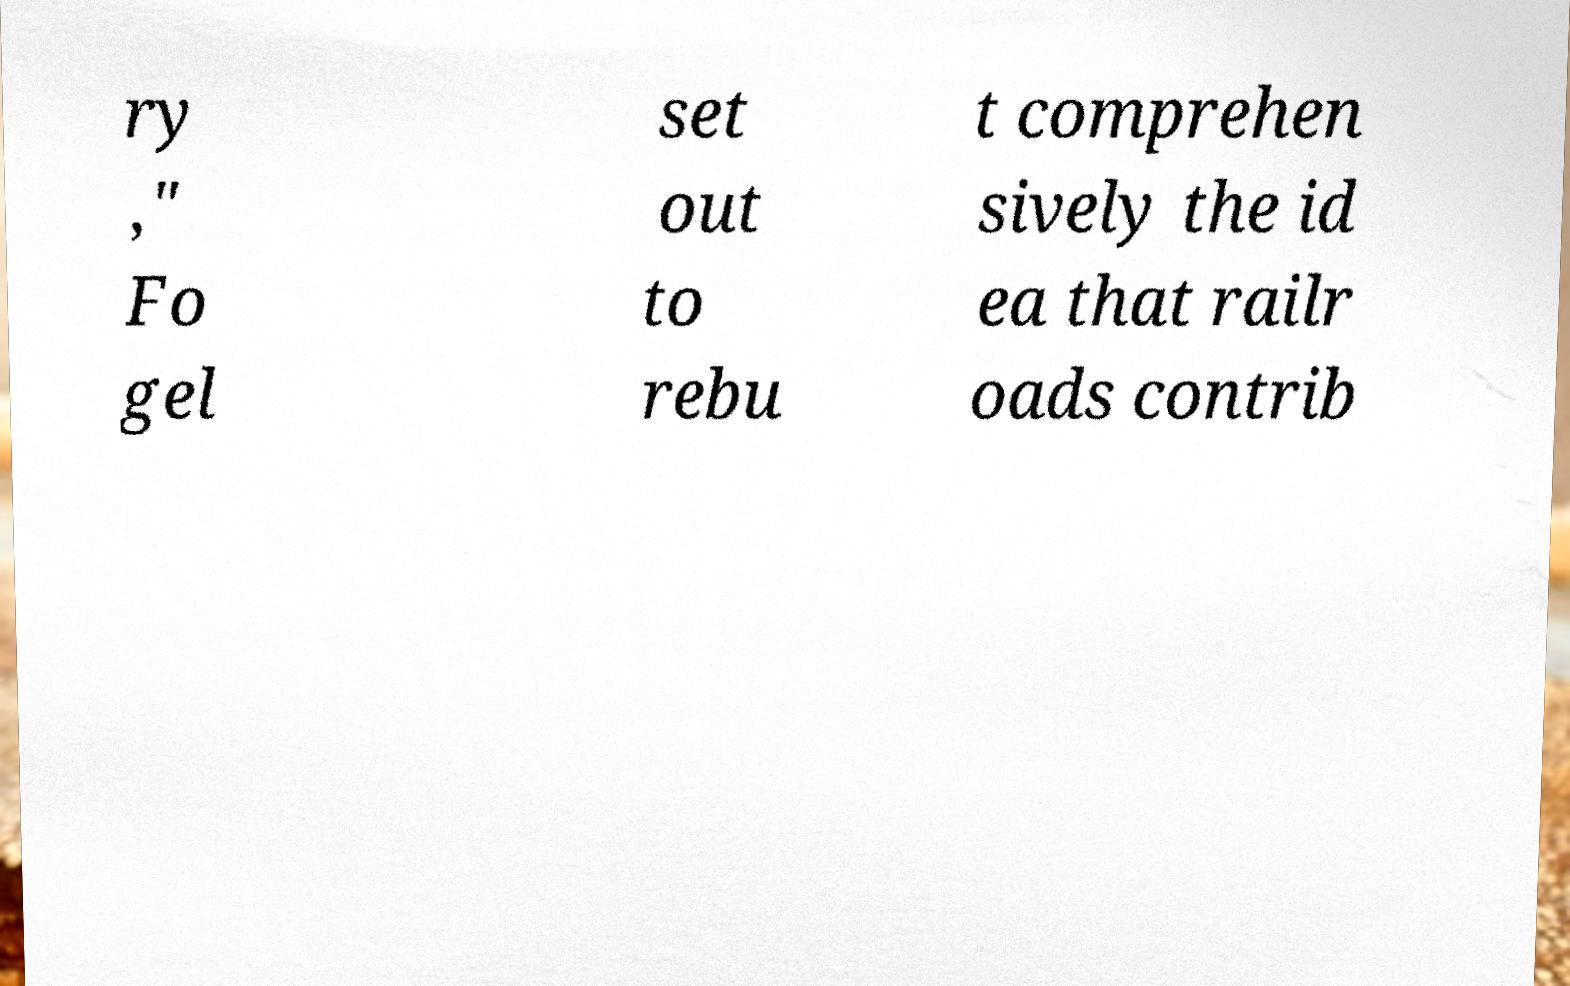Please read and relay the text visible in this image. What does it say? ry ," Fo gel set out to rebu t comprehen sively the id ea that railr oads contrib 